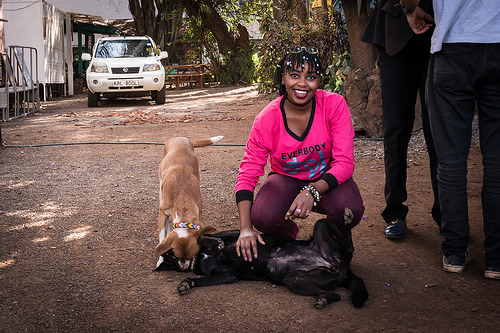<image>
Is the dog to the left of the dog? Yes. From this viewpoint, the dog is positioned to the left side relative to the dog. Is there a dog under the car? No. The dog is not positioned under the car. The vertical relationship between these objects is different. Is the car behind the woman? Yes. From this viewpoint, the car is positioned behind the woman, with the woman partially or fully occluding the car. 